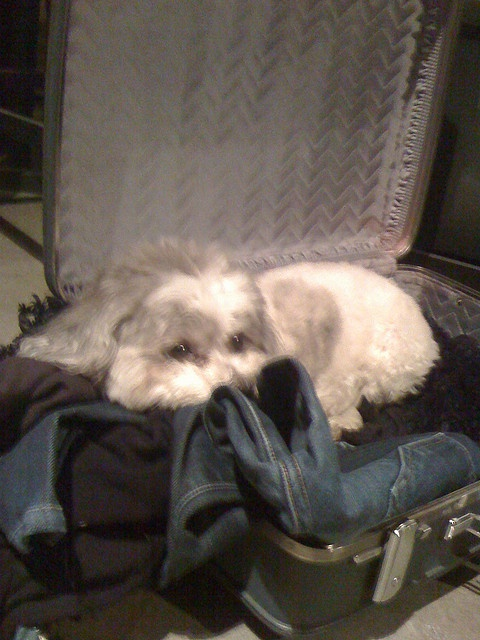Describe the objects in this image and their specific colors. I can see suitcase in black and gray tones, dog in black, darkgray, ivory, and tan tones, and suitcase in black, gray, and darkgreen tones in this image. 